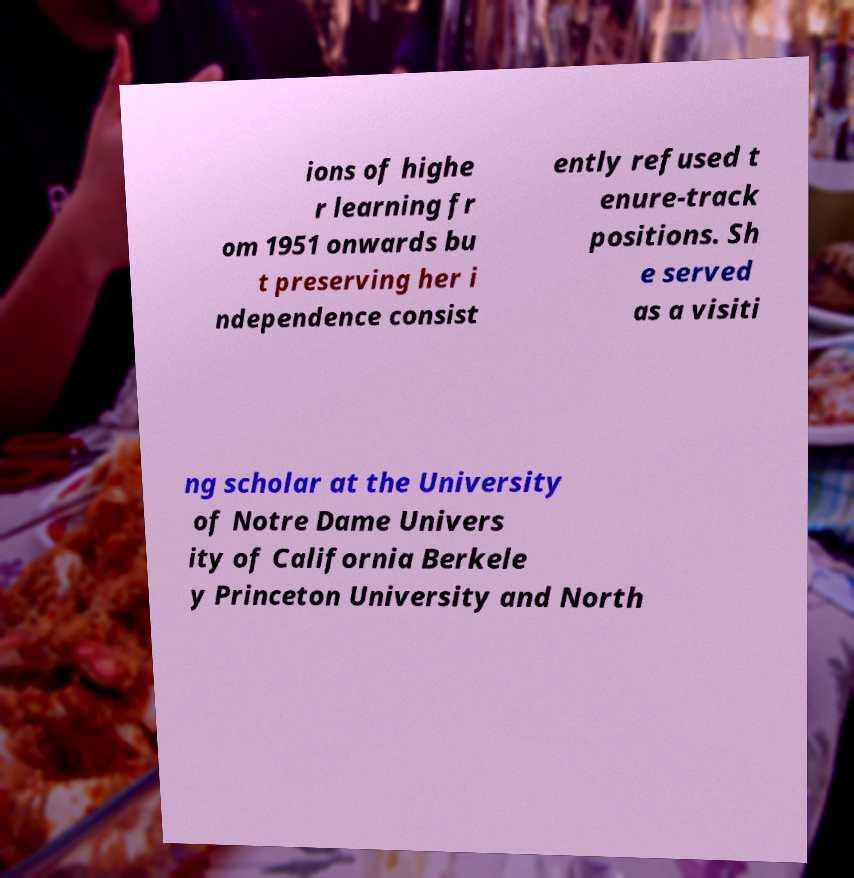Can you read and provide the text displayed in the image?This photo seems to have some interesting text. Can you extract and type it out for me? ions of highe r learning fr om 1951 onwards bu t preserving her i ndependence consist ently refused t enure-track positions. Sh e served as a visiti ng scholar at the University of Notre Dame Univers ity of California Berkele y Princeton University and North 